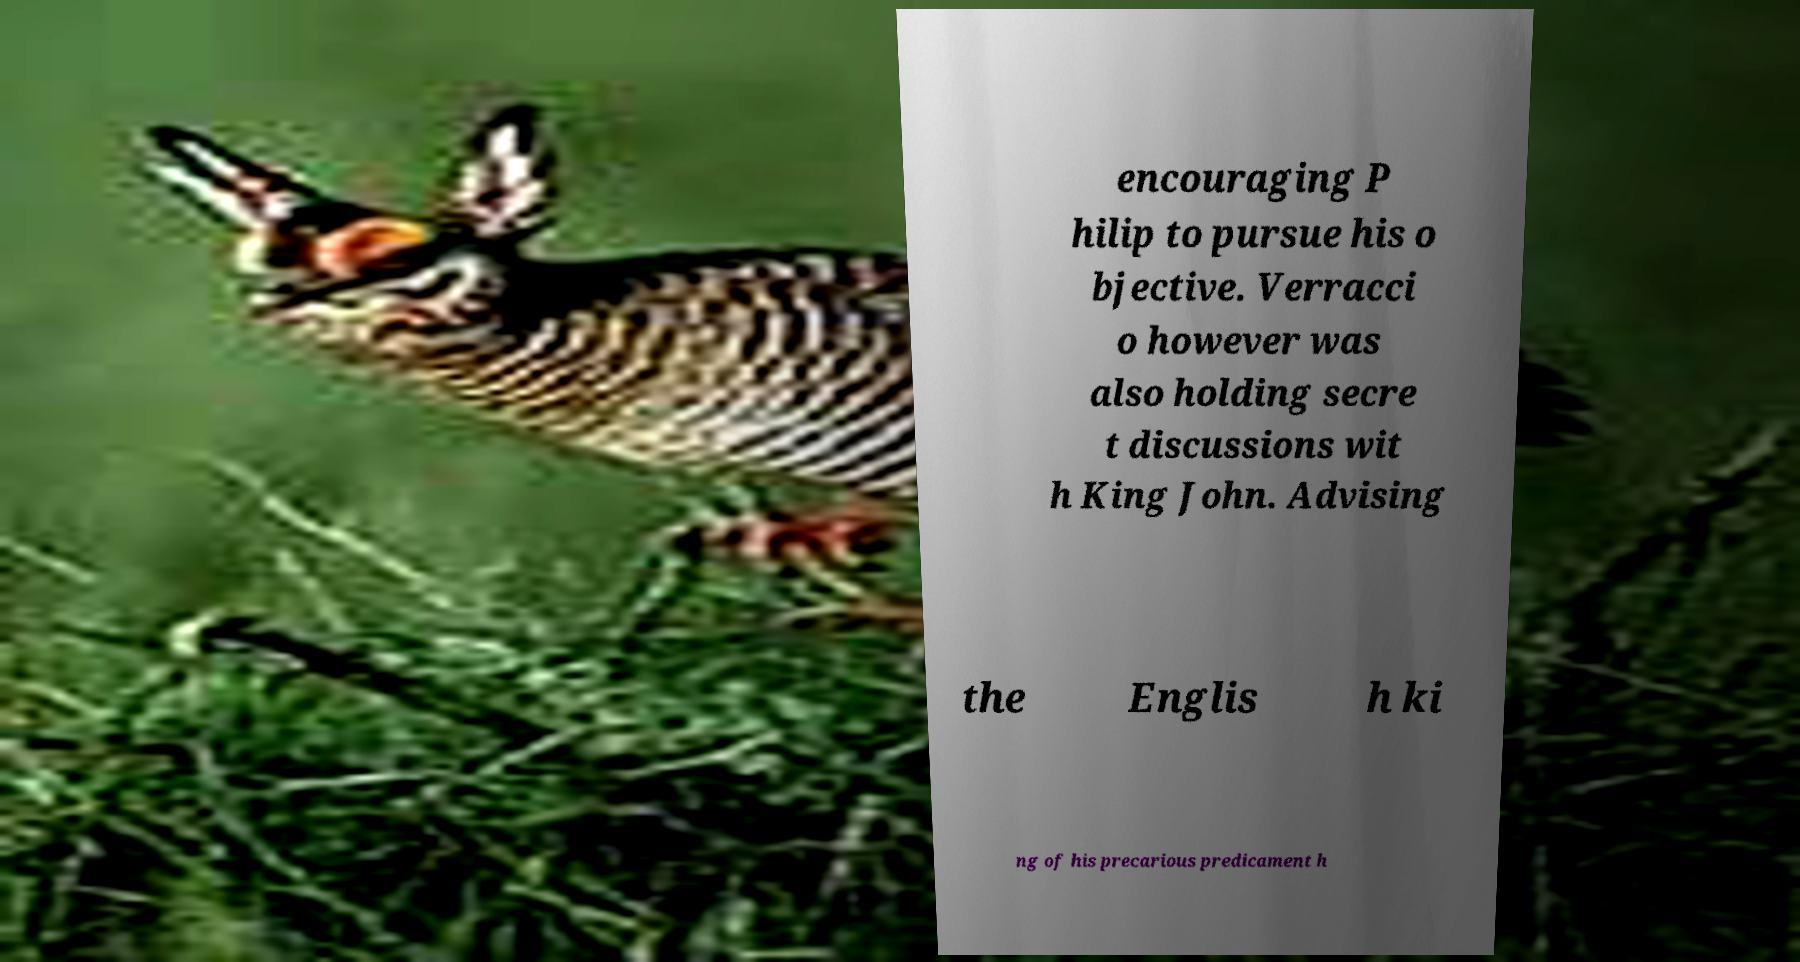I need the written content from this picture converted into text. Can you do that? encouraging P hilip to pursue his o bjective. Verracci o however was also holding secre t discussions wit h King John. Advising the Englis h ki ng of his precarious predicament h 